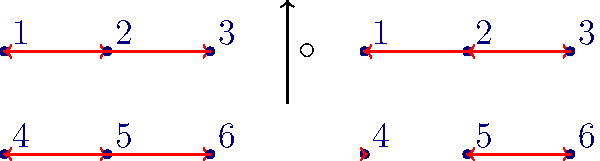Consider the two permutations $\sigma$ and $\tau$ represented by the arrow diagrams above. Calculate $\sigma \circ \tau$ and determine the cycle notation of the resulting permutation. To solve this problem, we'll follow these steps:

1) First, let's identify the permutations $\sigma$ and $\tau$:

   $\sigma = (1 2 3)(4 5 6)$
   $\tau = (1 3 2)(5 6)$

2) To compose $\sigma \circ \tau$, we apply $\tau$ first, then $\sigma$. Let's track each element:

   1 $\xrightarrow{\tau}$ 3 $\xrightarrow{\sigma}$ 1
   2 $\xrightarrow{\tau}$ 1 $\xrightarrow{\sigma}$ 2
   3 $\xrightarrow{\tau}$ 2 $\xrightarrow{\sigma}$ 3
   4 $\xrightarrow{\tau}$ 4 $\xrightarrow{\sigma}$ 5
   5 $\xrightarrow{\tau}$ 6 $\xrightarrow{\sigma}$ 4
   6 $\xrightarrow{\tau}$ 5 $\xrightarrow{\sigma}$ 6

3) From this, we can write the resulting permutation in two-line notation:

   $\begin{pmatrix} 
   1 & 2 & 3 & 4 & 5 & 6 \\
   1 & 2 & 3 & 5 & 4 & 6
   \end{pmatrix}$

4) To convert this to cycle notation, we follow each element until we return to the starting point:

   (1) (2) (3) (4 5) (6)

5) We can omit the 1-cycles, leaving us with the final result.
Answer: $(4 5)$ 